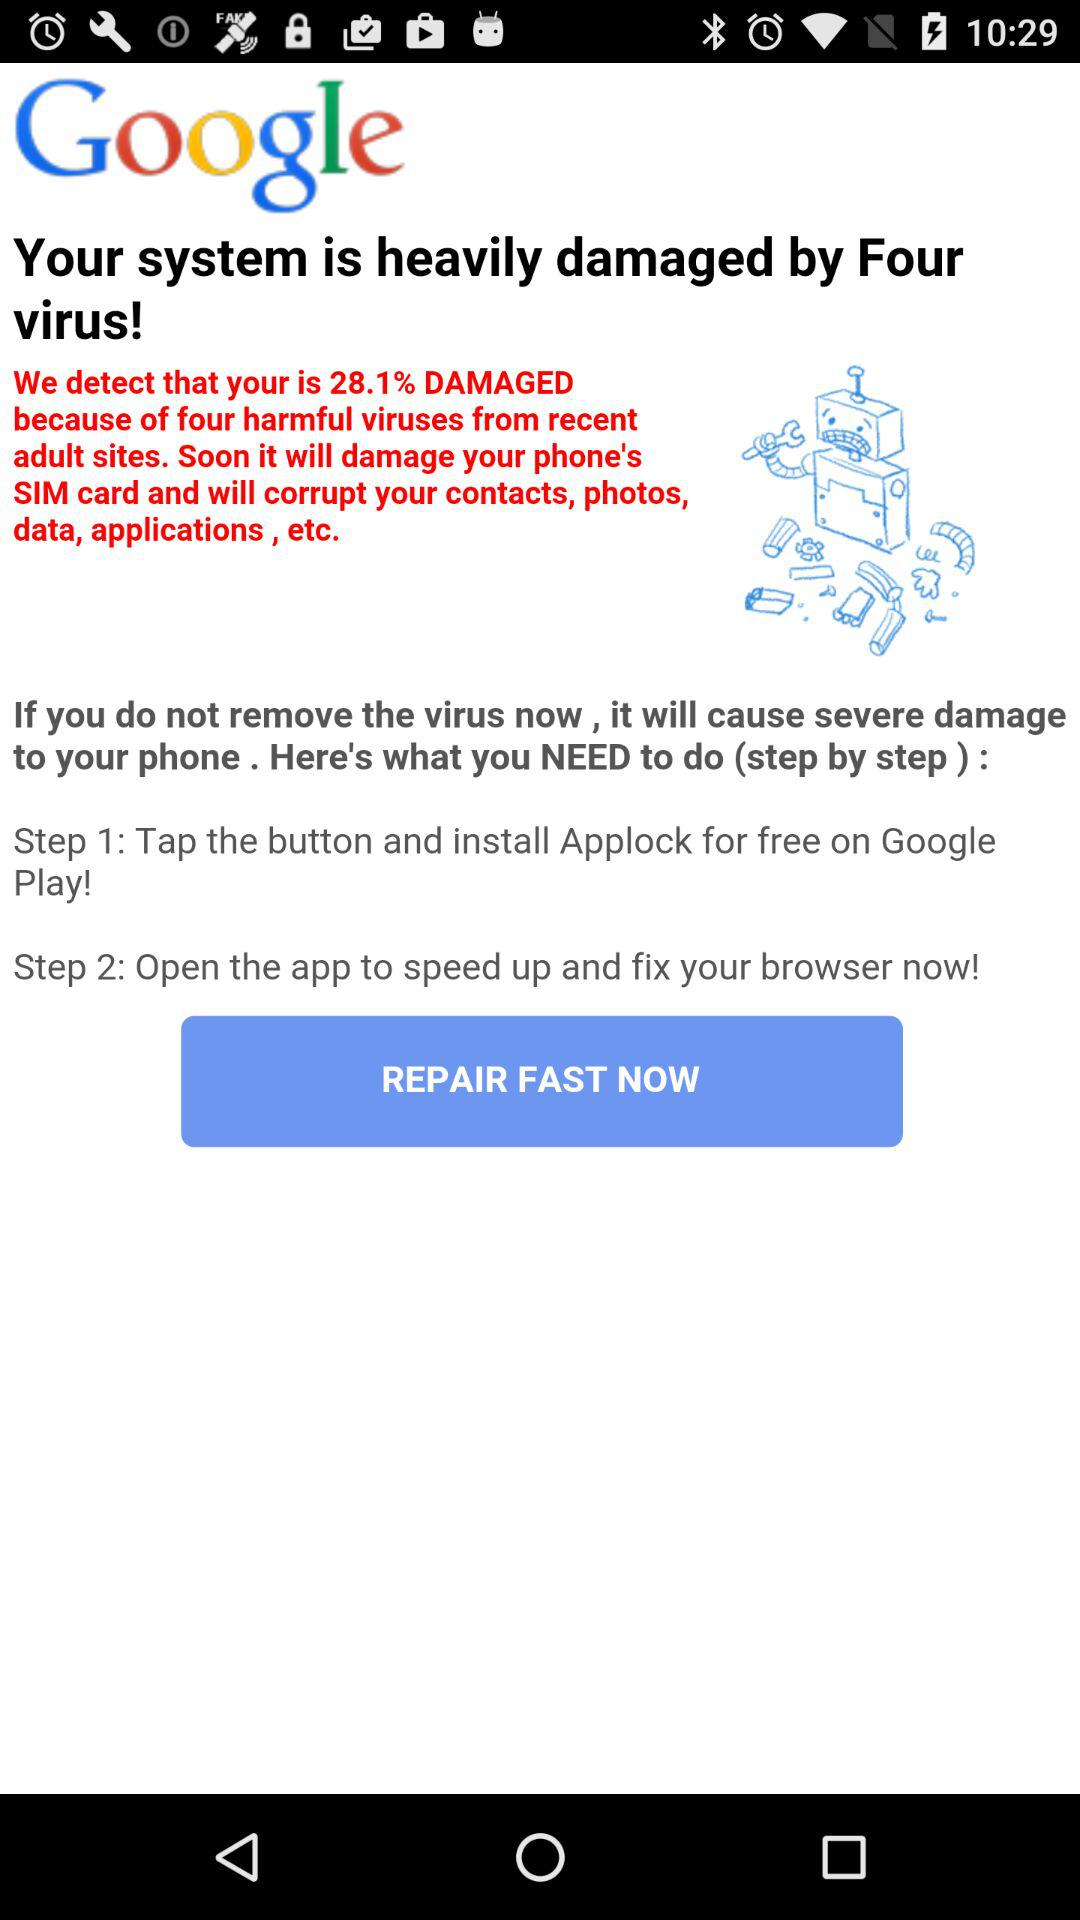How many steps do I need to follow to remove the virus?
Answer the question using a single word or phrase. 2 